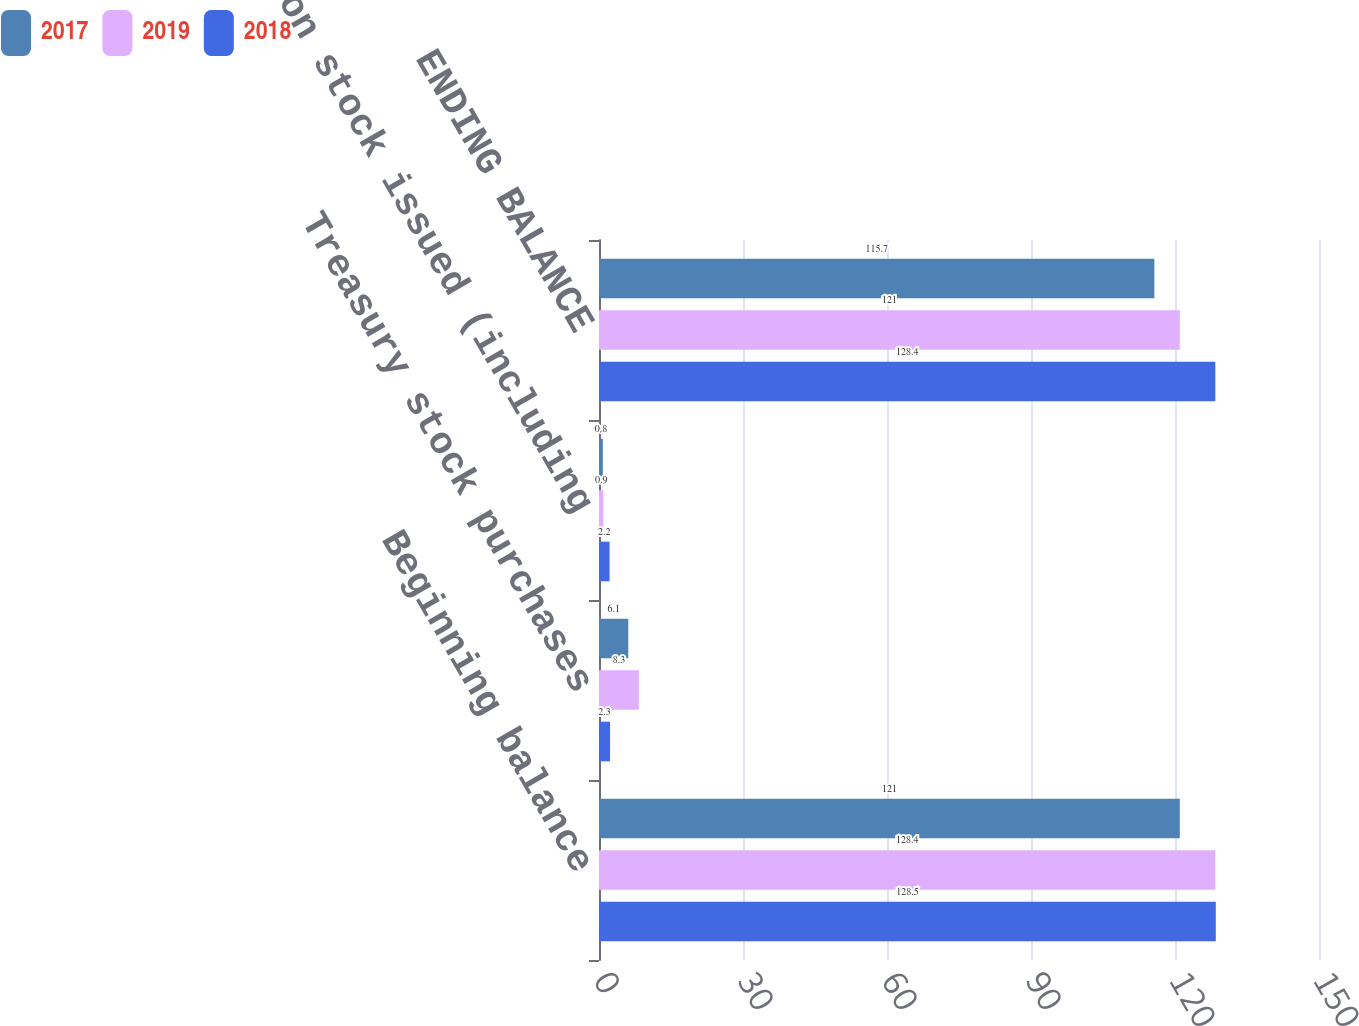Convert chart. <chart><loc_0><loc_0><loc_500><loc_500><stacked_bar_chart><ecel><fcel>Beginning balance<fcel>Treasury stock purchases<fcel>Common stock issued (including<fcel>ENDING BALANCE<nl><fcel>2017<fcel>121<fcel>6.1<fcel>0.8<fcel>115.7<nl><fcel>2019<fcel>128.4<fcel>8.3<fcel>0.9<fcel>121<nl><fcel>2018<fcel>128.5<fcel>2.3<fcel>2.2<fcel>128.4<nl></chart> 